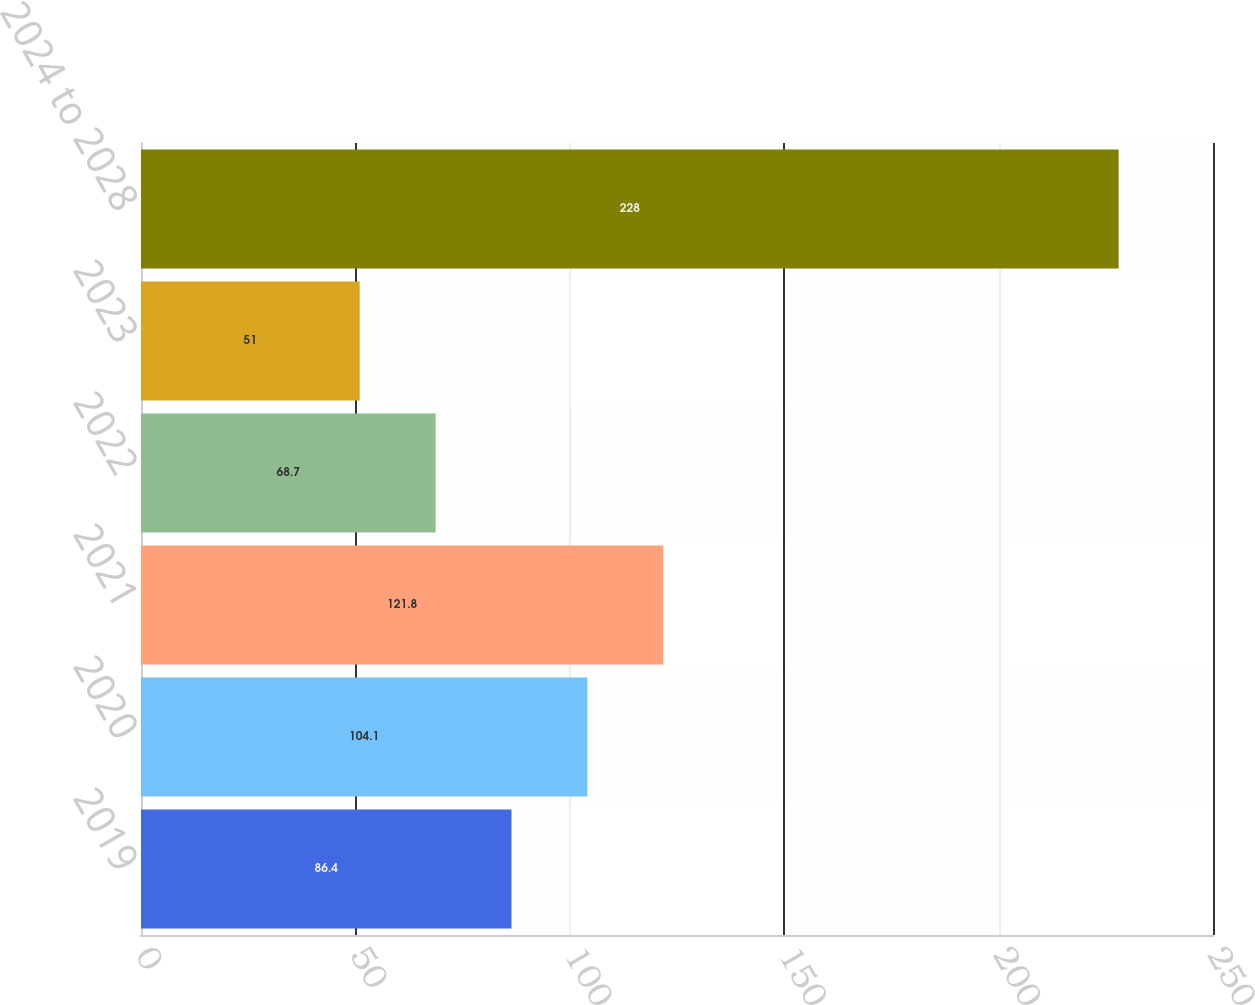Convert chart. <chart><loc_0><loc_0><loc_500><loc_500><bar_chart><fcel>2019<fcel>2020<fcel>2021<fcel>2022<fcel>2023<fcel>2024 to 2028<nl><fcel>86.4<fcel>104.1<fcel>121.8<fcel>68.7<fcel>51<fcel>228<nl></chart> 